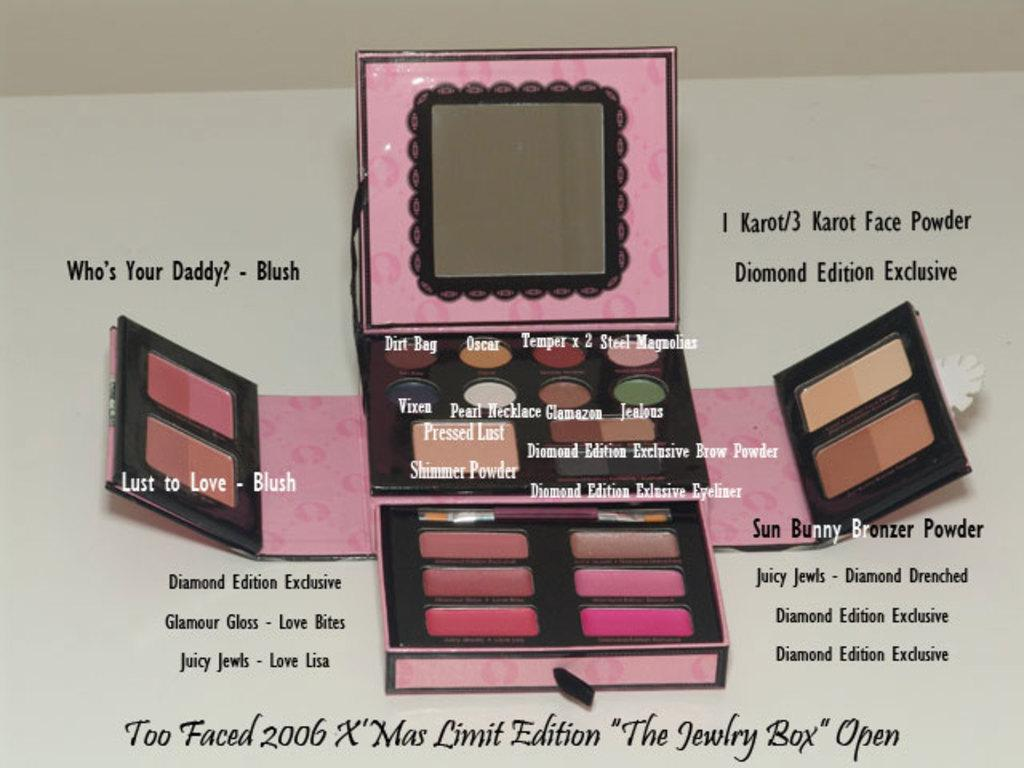<image>
Create a compact narrative representing the image presented. a makeup case with who's your daddy written next to it 